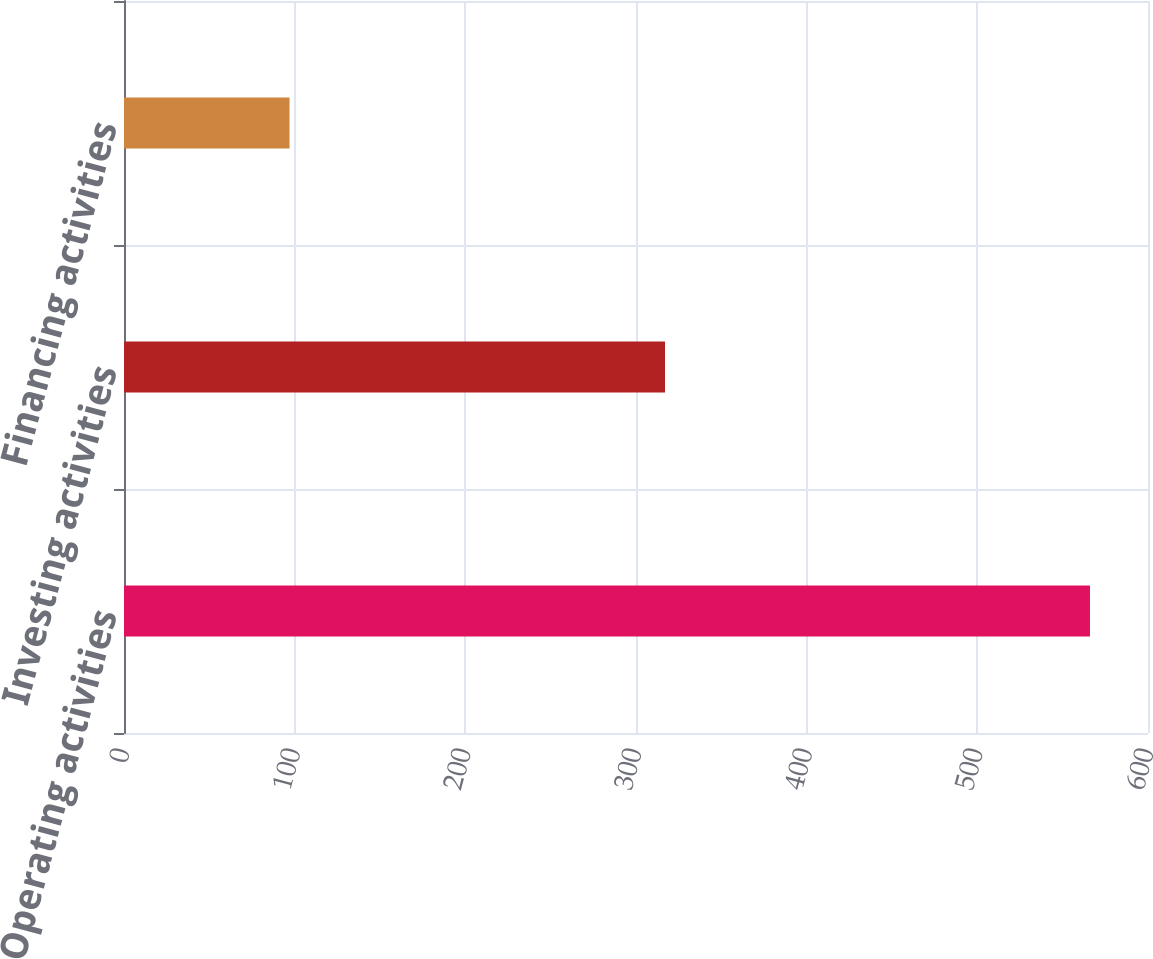Convert chart to OTSL. <chart><loc_0><loc_0><loc_500><loc_500><bar_chart><fcel>Operating activities<fcel>Investing activities<fcel>Financing activities<nl><fcel>566<fcel>317<fcel>97<nl></chart> 